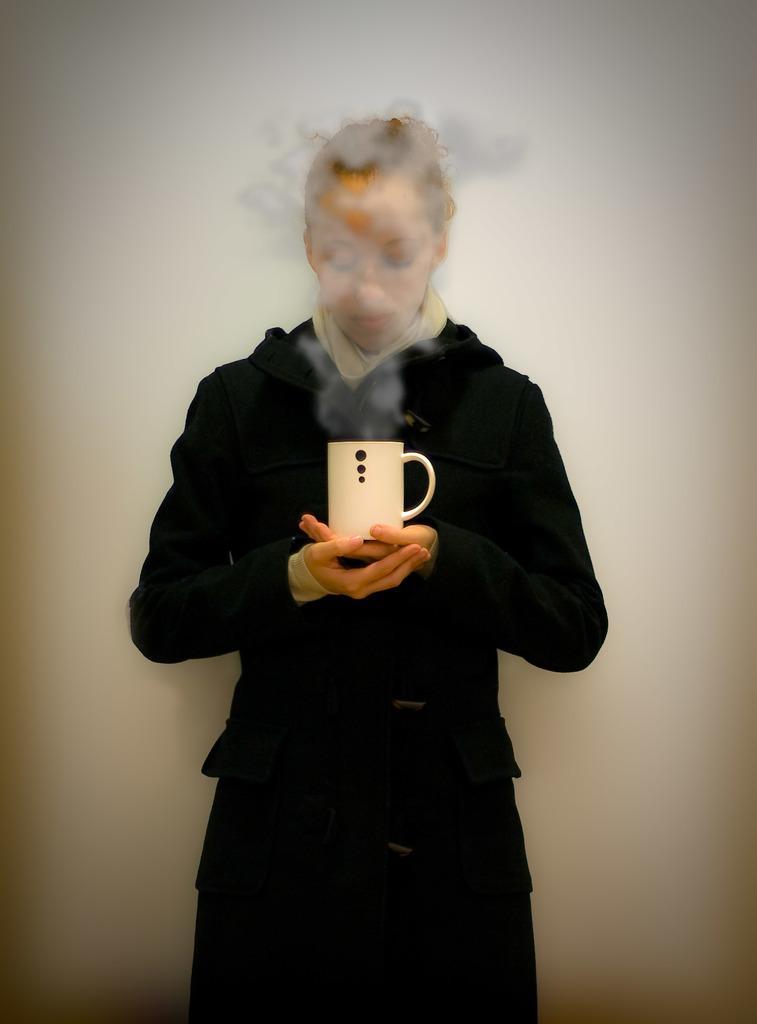Please provide a concise description of this image. This image consists of a woman who is wearing black color dress. She has a cup in her hand which is in white color. 